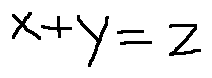Convert formula to latex. <formula><loc_0><loc_0><loc_500><loc_500>x + y = z</formula> 